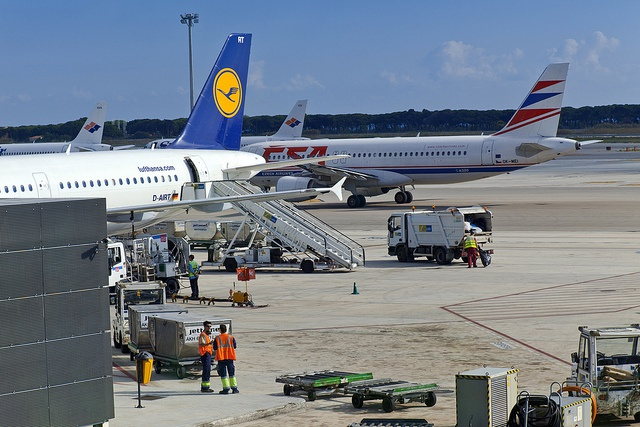Describe the objects in this image and their specific colors. I can see airplane in gray and black tones, airplane in gray, white, and darkgray tones, truck in gray, black, darkgray, and darkgreen tones, truck in gray, black, and darkgray tones, and airplane in gray and darkgray tones in this image. 